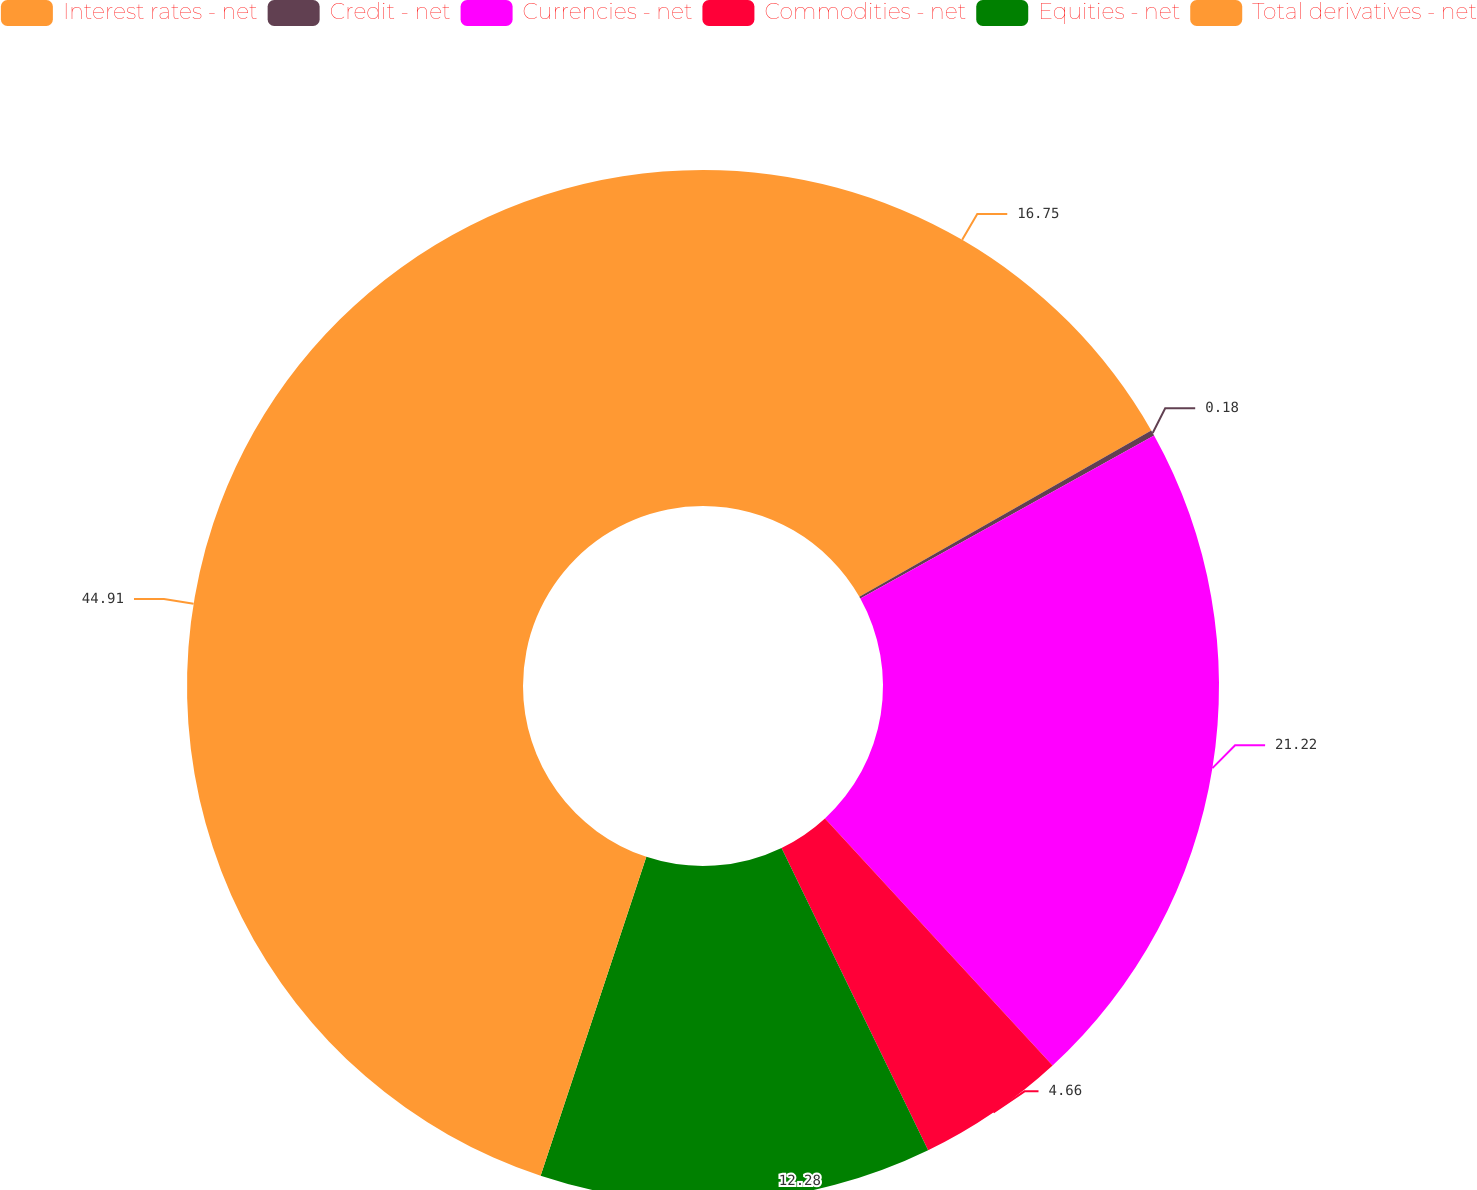Convert chart to OTSL. <chart><loc_0><loc_0><loc_500><loc_500><pie_chart><fcel>Interest rates - net<fcel>Credit - net<fcel>Currencies - net<fcel>Commodities - net<fcel>Equities - net<fcel>Total derivatives - net<nl><fcel>16.75%<fcel>0.18%<fcel>21.22%<fcel>4.66%<fcel>12.28%<fcel>44.9%<nl></chart> 